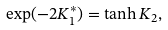<formula> <loc_0><loc_0><loc_500><loc_500>\exp ( - 2 K _ { 1 } ^ { * } ) = \tanh K _ { 2 } ,</formula> 